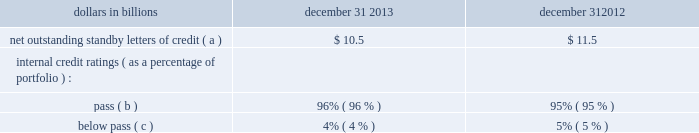2022 through the u.s .
Attorney 2019s office for the district of maryland , the office of the inspector general ( 201coig 201d ) for the small business administration ( 201csba 201d ) has served a subpoena on pnc requesting documents concerning pnc 2019s relationship with , including sba-guaranteed loans made through , a broker named jade capital investments , llc ( 201cjade 201d ) , as well as information regarding other pnc-originated sba guaranteed loans made to businesses located in the state of maryland , the commonwealth of virginia , and washington , dc .
Certain of the jade loans have been identified in an indictment and subsequent superseding indictment charging persons associated with jade with conspiracy to commit bank fraud , substantive violations of the federal bank fraud statute , and money laundering .
Pnc is cooperating with the u.s .
Attorney 2019s office for the district of maryland .
Our practice is to cooperate fully with regulatory and governmental investigations , audits and other inquiries , including those described in this note 23 .
In addition to the proceedings or other matters described above , pnc and persons to whom we may have indemnification obligations , in the normal course of business , are subject to various other pending and threatened legal proceedings in which claims for monetary damages and other relief are asserted .
We do not anticipate , at the present time , that the ultimate aggregate liability , if any , arising out of such other legal proceedings will have a material adverse effect on our financial position .
However , we cannot now determine whether or not any claims asserted against us or others to whom we may have indemnification obligations , whether in the proceedings or other matters described above or otherwise , will have a material adverse effect on our results of operations in any future reporting period , which will depend on , among other things , the amount of the loss resulting from the claim and the amount of income otherwise reported for the reporting period .
See note 24 commitments and guarantees for additional information regarding the visa indemnification and our other obligations to provide indemnification , including to current and former officers , directors , employees and agents of pnc and companies we have acquired .
Note 24 commitments and guarantees equity funding and other commitments our unfunded commitments at december 31 , 2013 included private equity investments of $ 164 million .
Standby letters of credit we issue standby letters of credit and have risk participations in standby letters of credit issued by other financial institutions , in each case to support obligations of our customers to third parties , such as insurance requirements and the facilitation of transactions involving capital markets product execution .
Net outstanding standby letters of credit and internal credit ratings were as follows : table 151 : net outstanding standby letters of credit dollars in billions december 31 december 31 net outstanding standby letters of credit ( a ) $ 10.5 $ 11.5 internal credit ratings ( as a percentage of portfolio ) : .
( a ) the amounts above exclude participations in standby letters of credit of $ 3.3 billion and $ 3.2 billion to other financial institutions as of december 31 , 2013 and december 31 , 2012 , respectively .
The amounts above include $ 6.6 billion and $ 7.5 billion which support remarketing programs at december 31 , 2013 and december 31 , 2012 , respectively .
( b ) indicates that expected risk of loss is currently low .
( c ) indicates a higher degree of risk of default .
If the customer fails to meet its financial or performance obligation to the third party under the terms of the contract or there is a need to support a remarketing program , then upon a draw by a beneficiary , subject to the terms of the letter of credit , we would be obligated to make payment to them .
The standby letters of credit outstanding on december 31 , 2013 had terms ranging from less than 1 year to 6 years .
As of december 31 , 2013 , assets of $ 2.0 billion secured certain specifically identified standby letters of credit .
In addition , a portion of the remaining standby letters of credit issued on behalf of specific customers is also secured by collateral or guarantees that secure the customers 2019 other obligations to us .
The carrying amount of the liability for our obligations related to standby letters of credit and participations in standby letters of credit was $ 218 million at december 31 , 2013 .
Standby bond purchase agreements and other liquidity facilities we enter into standby bond purchase agreements to support municipal bond obligations .
At december 31 , 2013 , the aggregate of our commitments under these facilities was $ 1.3 billion .
We also enter into certain other liquidity facilities to support individual pools of receivables acquired by commercial paper conduits .
There were no commitments under these facilities at december 31 , 2013 .
212 the pnc financial services group , inc .
2013 form 10-k .
What was the change in billions in remarketing programs between december 31 , 2013 and december 31 , 2012? 
Computations: (7.5 - 6.6)
Answer: 0.9. 